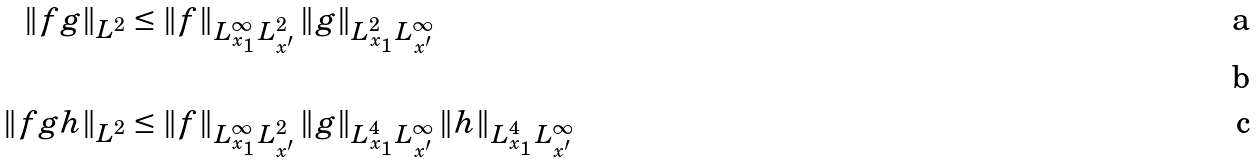Convert formula to latex. <formula><loc_0><loc_0><loc_500><loc_500>\| f g \| _ { L ^ { 2 } } & \leq \| f \| _ { L ^ { \infty } _ { x _ { 1 } } \, L ^ { 2 } _ { x ^ { \prime } } } \, \| g \| _ { L ^ { 2 } _ { x _ { 1 } } \, L ^ { \infty } _ { x ^ { \prime } } } \\ \\ \| f g h \| _ { L ^ { 2 } } & \leq \| f \| _ { L ^ { \infty } _ { x _ { 1 } } \, L ^ { 2 } _ { x ^ { \prime } } } \, \| g \| _ { L ^ { 4 } _ { x _ { 1 } } \, L ^ { \infty } _ { x ^ { \prime } } } \, \| h \| _ { L ^ { 4 } _ { x _ { 1 } } \, L ^ { \infty } _ { x ^ { \prime } } }</formula> 